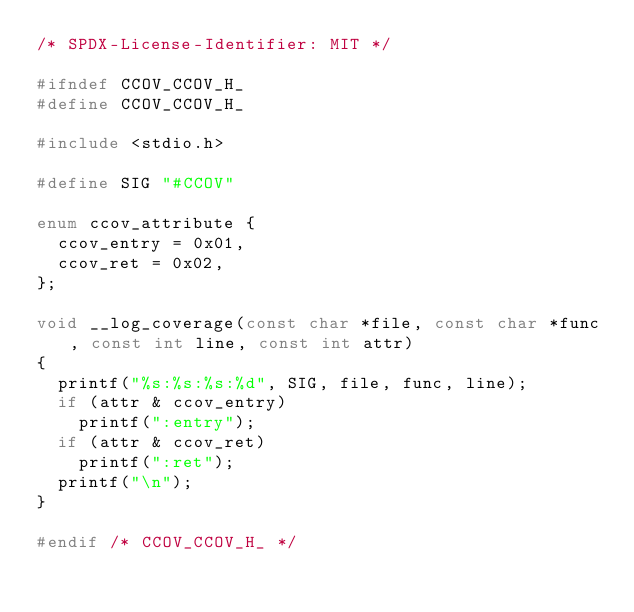<code> <loc_0><loc_0><loc_500><loc_500><_C_>/* SPDX-License-Identifier: MIT */

#ifndef CCOV_CCOV_H_
#define CCOV_CCOV_H_

#include <stdio.h>

#define SIG "#CCOV"

enum ccov_attribute {
  ccov_entry = 0x01,
  ccov_ret = 0x02,
};

void __log_coverage(const char *file, const char *func, const int line, const int attr)
{
  printf("%s:%s:%s:%d", SIG, file, func, line);
  if (attr & ccov_entry)
    printf(":entry");
  if (attr & ccov_ret)
    printf(":ret");
  printf("\n");
}

#endif /* CCOV_CCOV_H_ */
</code> 